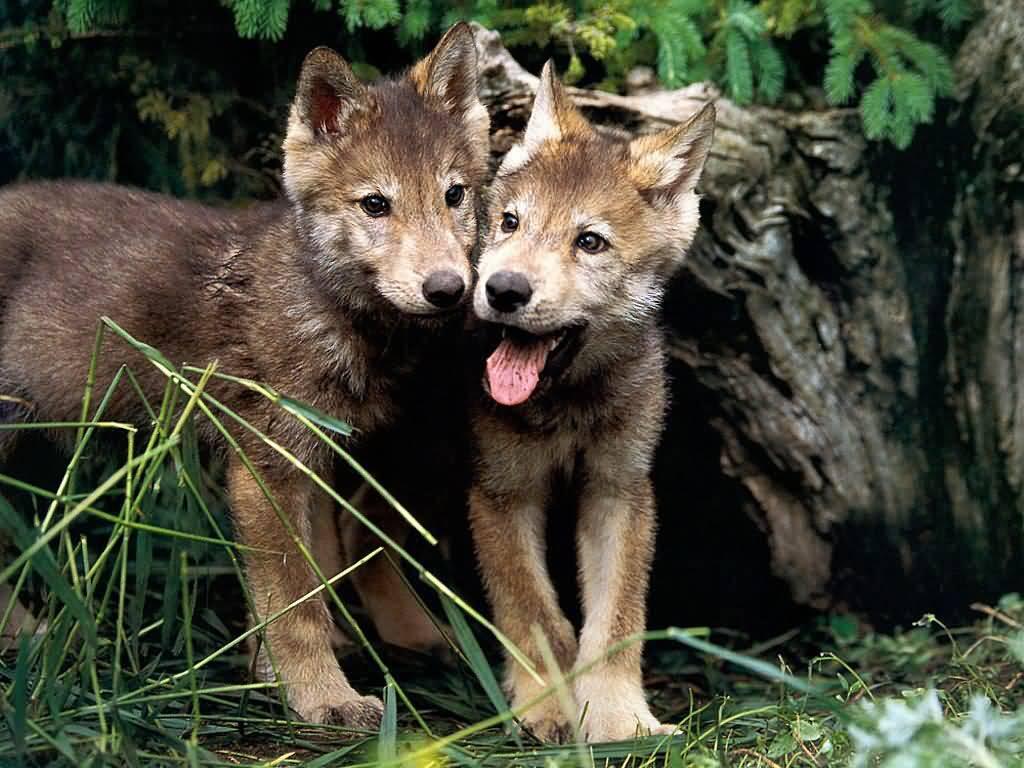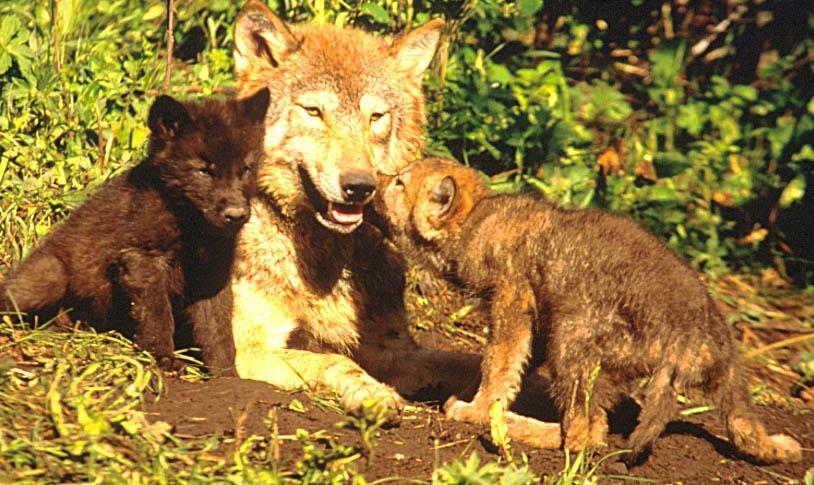The first image is the image on the left, the second image is the image on the right. Given the left and right images, does the statement "One image shows at least two forward-facing wolf pups standing side-by-side and no adult wolves, and the other image shows an adult wolf and pups, with its muzzle touching one pup." hold true? Answer yes or no. Yes. 